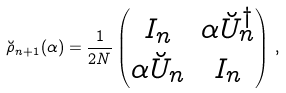Convert formula to latex. <formula><loc_0><loc_0><loc_500><loc_500>\breve { \rho } _ { n + 1 } ( \alpha ) = \frac { 1 } { 2 N } \begin{pmatrix} I _ { n } & \alpha \breve { U } _ { n } ^ { \dag } \\ \alpha \breve { U } _ { n } & I _ { n } \end{pmatrix} \, ,</formula> 